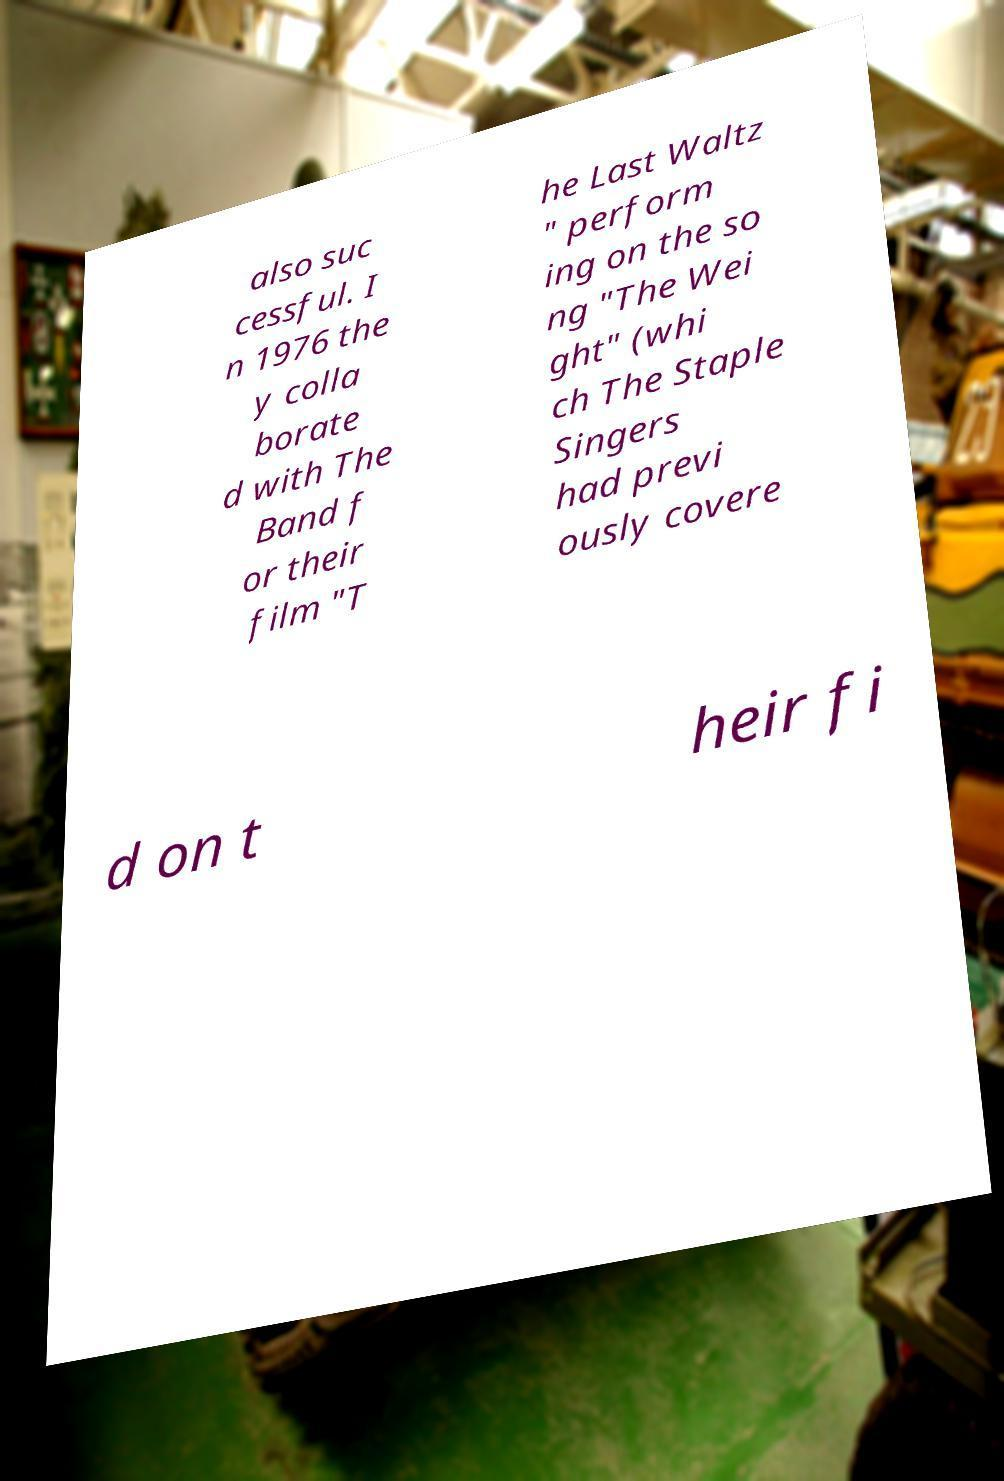Could you extract and type out the text from this image? also suc cessful. I n 1976 the y colla borate d with The Band f or their film "T he Last Waltz " perform ing on the so ng "The Wei ght" (whi ch The Staple Singers had previ ously covere d on t heir fi 